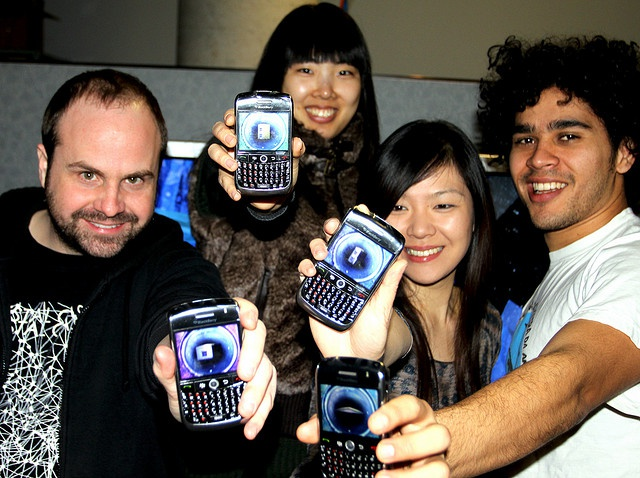Describe the objects in this image and their specific colors. I can see people in black, salmon, ivory, and gray tones, people in black, ivory, tan, and brown tones, people in black, gray, and maroon tones, people in black, tan, and beige tones, and cell phone in black, white, navy, and lightblue tones in this image. 